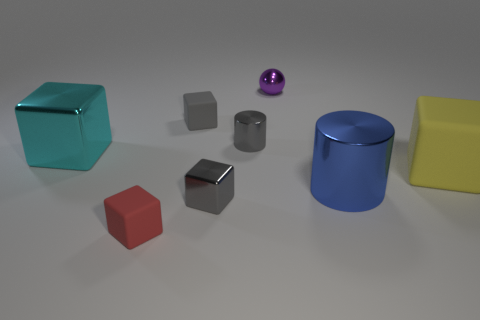What is the shape of the big cyan object that is made of the same material as the tiny purple ball?
Give a very brief answer. Cube. Is the number of large cyan metal cubes less than the number of rubber cubes?
Offer a very short reply. Yes. What is the large object that is left of the big rubber object and to the right of the large cyan block made of?
Your answer should be very brief. Metal. There is a matte cube right of the small gray block that is to the right of the tiny cube that is behind the large yellow rubber object; what is its size?
Your answer should be compact. Large. Does the red object have the same shape as the large shiny object that is to the right of the small gray matte thing?
Your answer should be very brief. No. How many blocks are to the left of the tiny gray metallic block and behind the small red cube?
Make the answer very short. 2. How many red things are either large things or tiny rubber blocks?
Make the answer very short. 1. Does the cylinder that is to the right of the purple metallic ball have the same color as the rubber object behind the yellow rubber thing?
Keep it short and to the point. No. What is the color of the large block to the right of the tiny matte block in front of the big thing that is right of the big blue thing?
Provide a short and direct response. Yellow. There is a shiny object to the left of the small red cube; are there any large cylinders on the left side of it?
Your response must be concise. No. 